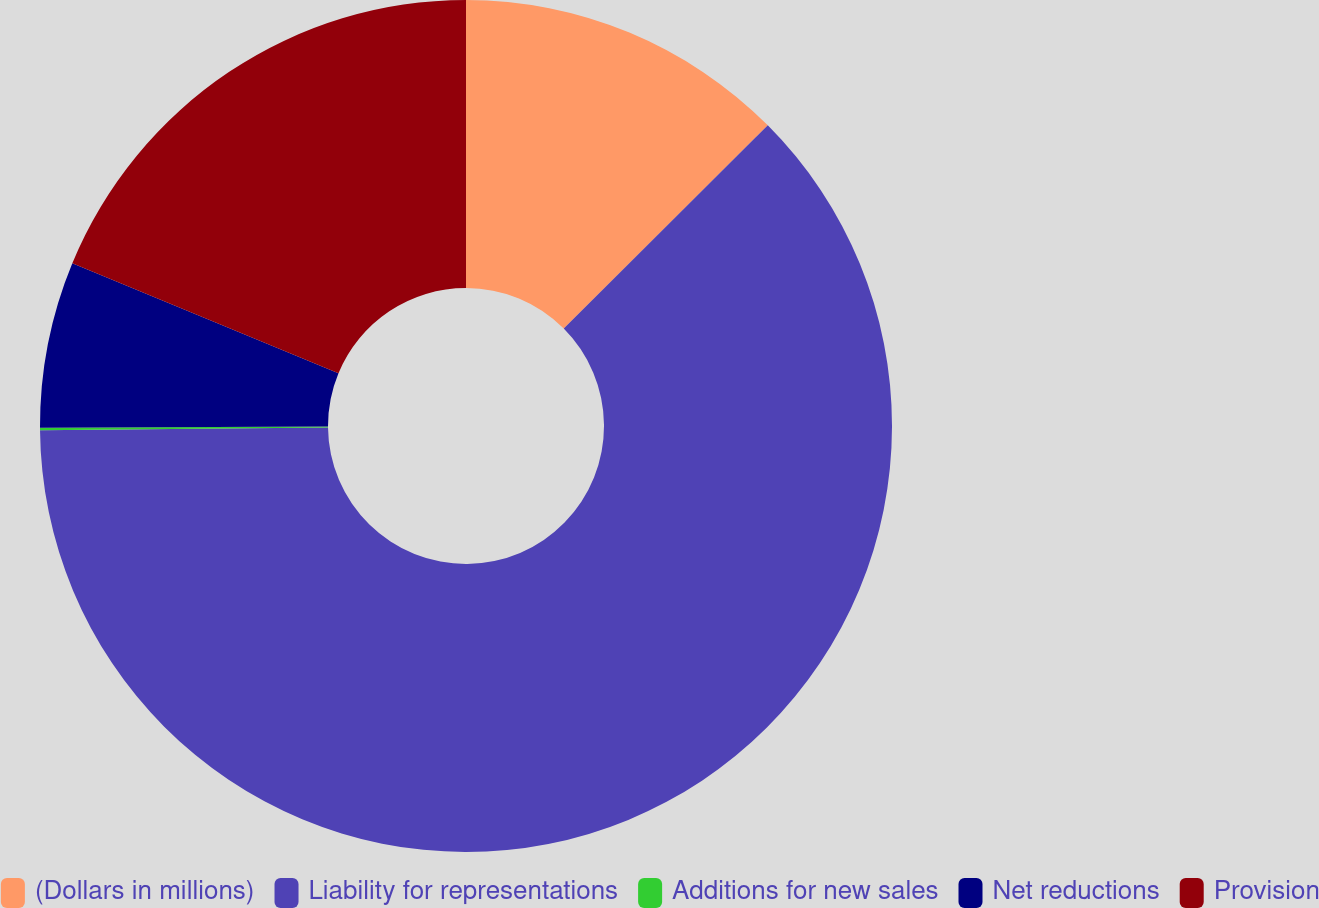Convert chart to OTSL. <chart><loc_0><loc_0><loc_500><loc_500><pie_chart><fcel>(Dollars in millions)<fcel>Liability for representations<fcel>Additions for new sales<fcel>Net reductions<fcel>Provision<nl><fcel>12.53%<fcel>62.31%<fcel>0.09%<fcel>6.31%<fcel>18.76%<nl></chart> 